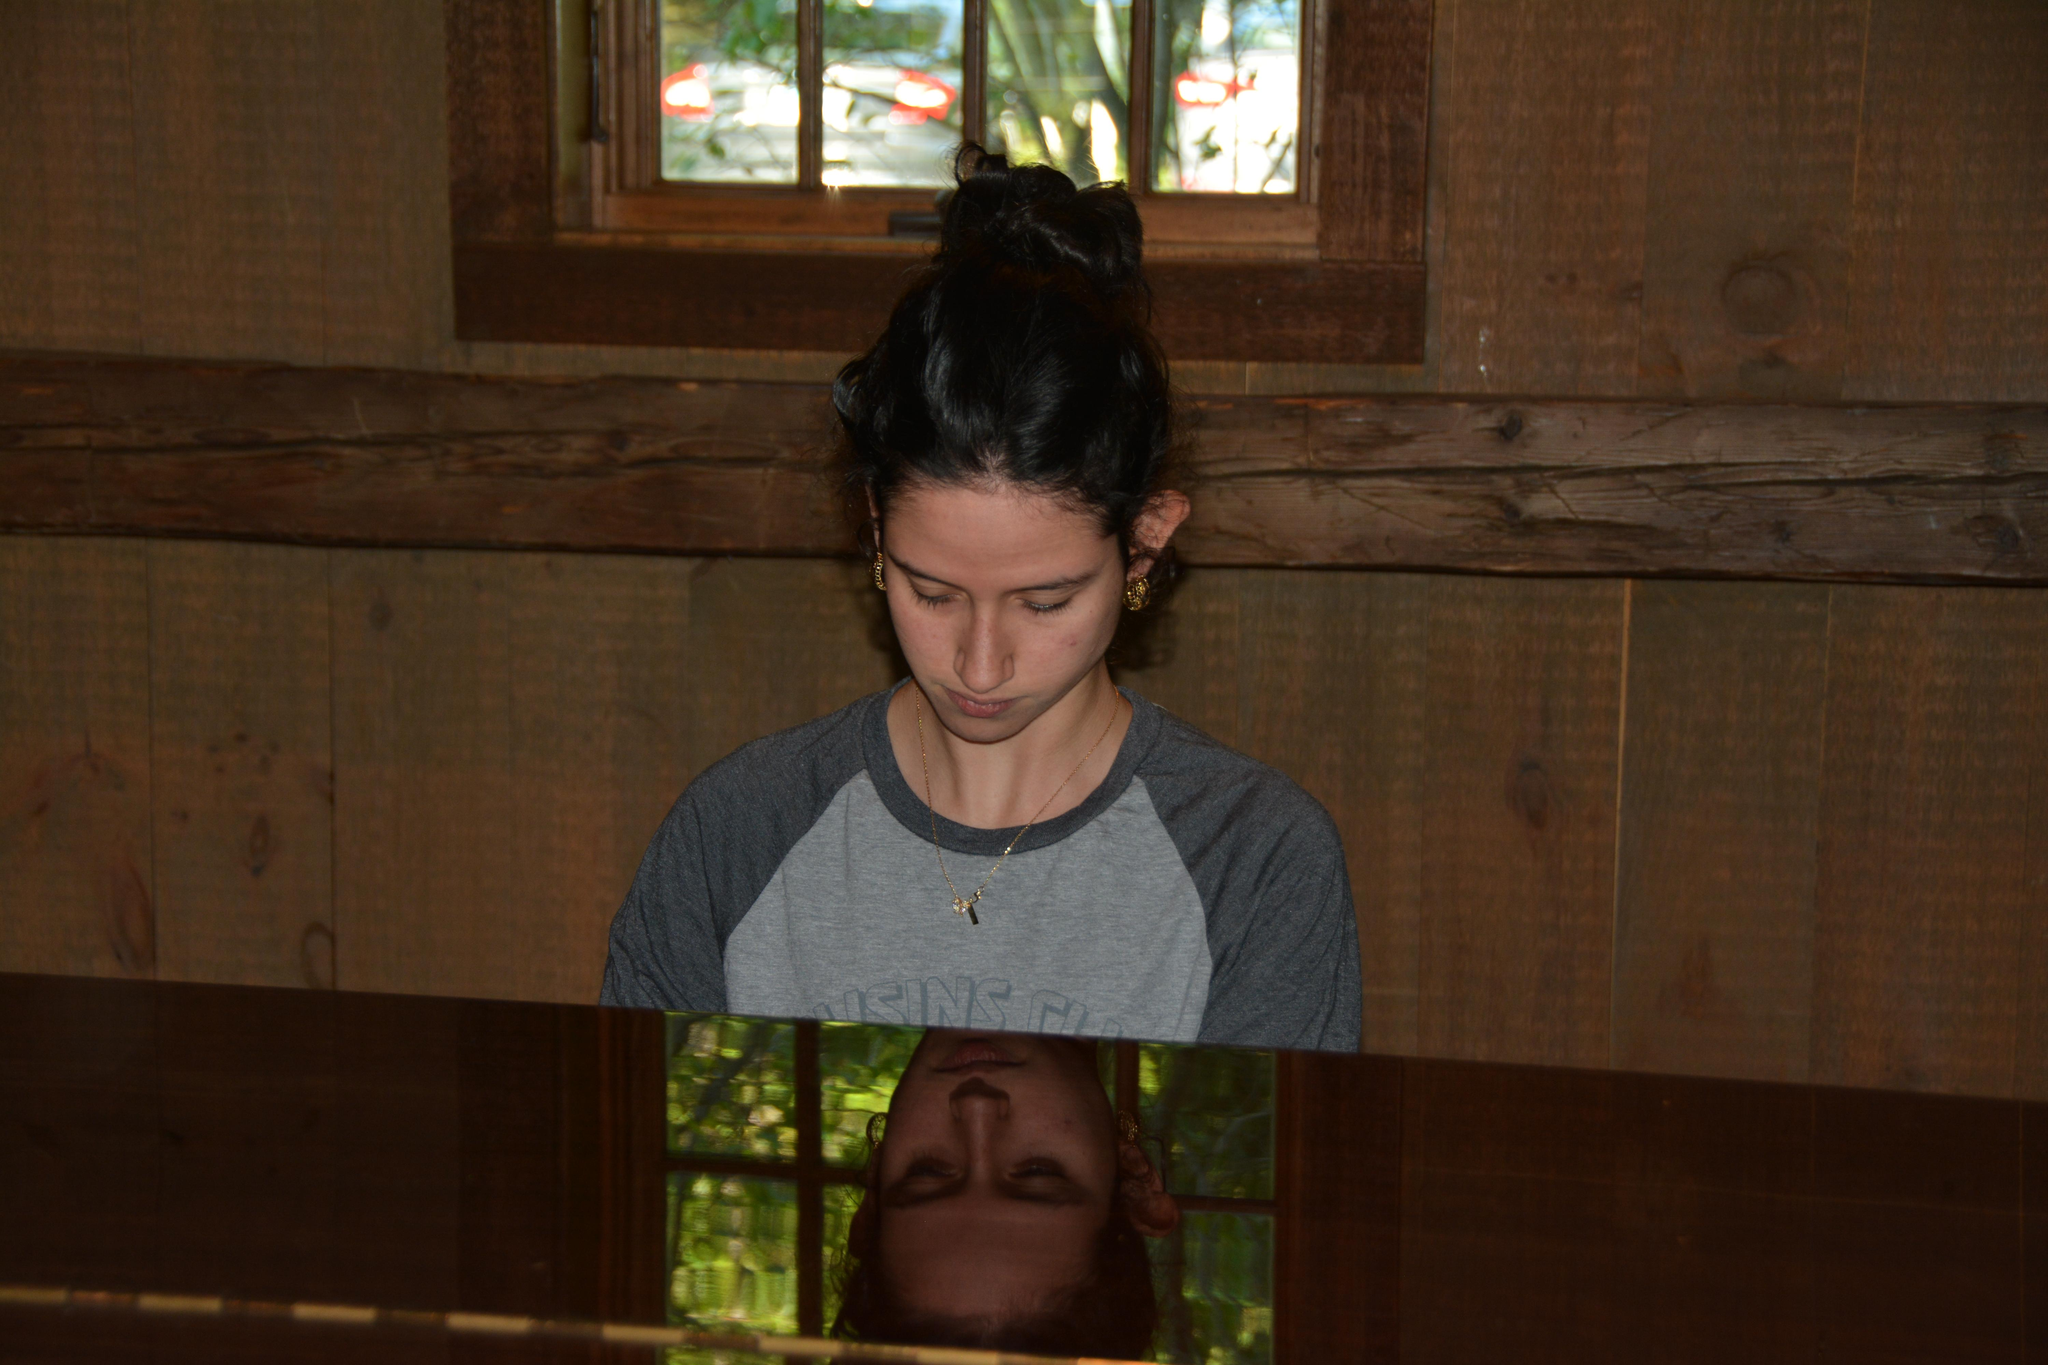What is the person in the image doing? The person is sitting at a table in the image. Where is the table located in the image? The table is at the bottom of the image. What can be seen in the background of the image? There is a wooden wall, a window, and a plant in the background of the image. What type of cherry is the person eating in the image? There is no cherry present in the image. What color is the collar of the person in the image? The provided facts do not mention any collar, so we cannot determine the color of a collar in the image. 